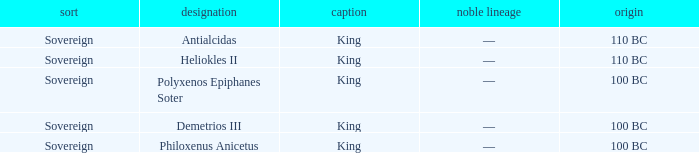When did Demetrios III begin to hold power? 100 BC. 